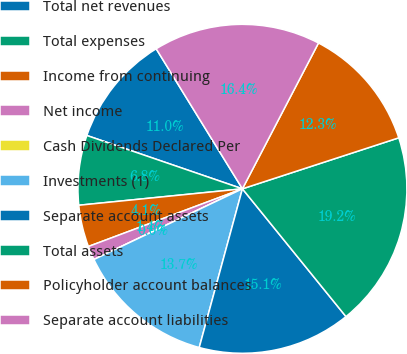Convert chart. <chart><loc_0><loc_0><loc_500><loc_500><pie_chart><fcel>Total net revenues<fcel>Total expenses<fcel>Income from continuing<fcel>Net income<fcel>Cash Dividends Declared Per<fcel>Investments (1)<fcel>Separate account assets<fcel>Total assets<fcel>Policyholder account balances<fcel>Separate account liabilities<nl><fcel>10.96%<fcel>6.85%<fcel>4.11%<fcel>1.37%<fcel>0.0%<fcel>13.7%<fcel>15.07%<fcel>19.18%<fcel>12.33%<fcel>16.44%<nl></chart> 